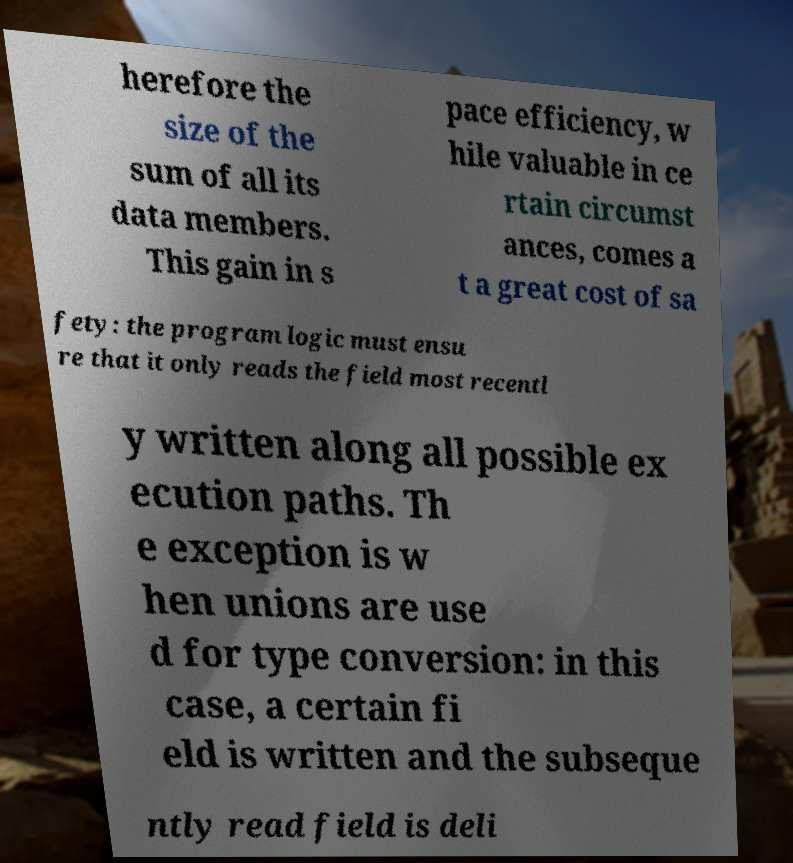Could you assist in decoding the text presented in this image and type it out clearly? herefore the size of the sum of all its data members. This gain in s pace efficiency, w hile valuable in ce rtain circumst ances, comes a t a great cost of sa fety: the program logic must ensu re that it only reads the field most recentl y written along all possible ex ecution paths. Th e exception is w hen unions are use d for type conversion: in this case, a certain fi eld is written and the subseque ntly read field is deli 